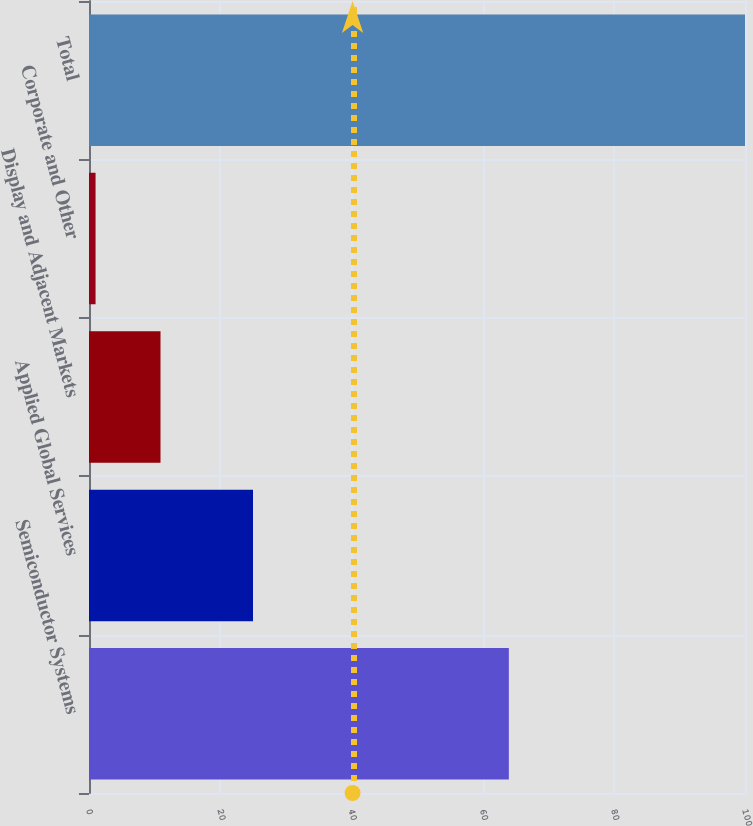<chart> <loc_0><loc_0><loc_500><loc_500><bar_chart><fcel>Semiconductor Systems<fcel>Applied Global Services<fcel>Display and Adjacent Markets<fcel>Corporate and Other<fcel>Total<nl><fcel>64<fcel>25<fcel>10.9<fcel>1<fcel>100<nl></chart> 